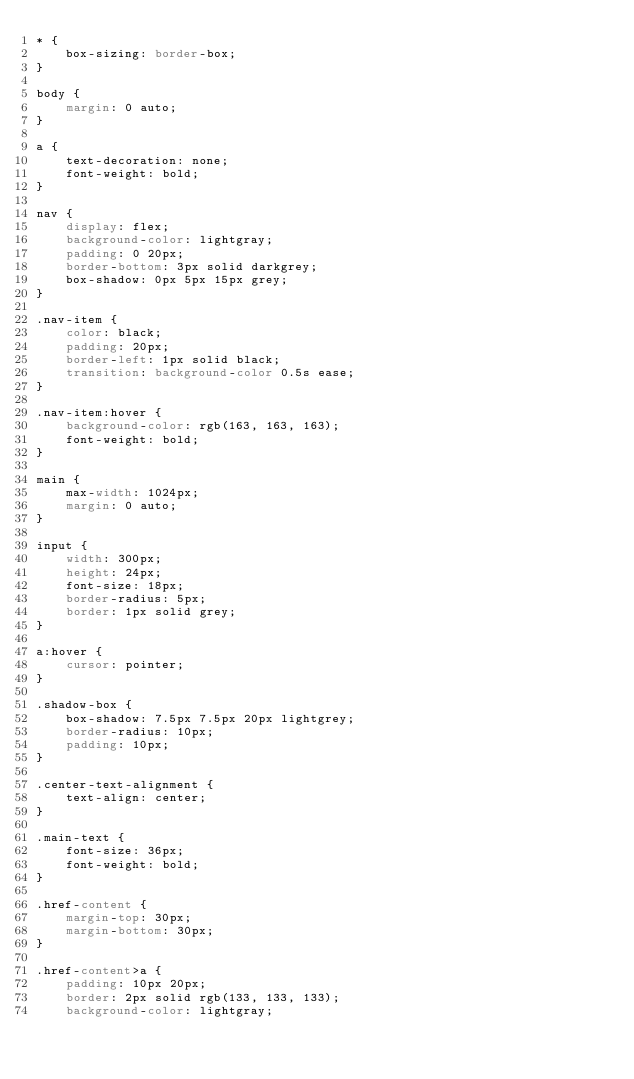<code> <loc_0><loc_0><loc_500><loc_500><_CSS_>* {
    box-sizing: border-box;
}

body {
    margin: 0 auto;
}

a {
    text-decoration: none;
    font-weight: bold;
}

nav {
    display: flex;
    background-color: lightgray;
    padding: 0 20px;
    border-bottom: 3px solid darkgrey;
    box-shadow: 0px 5px 15px grey;
}

.nav-item {
    color: black;
    padding: 20px;
    border-left: 1px solid black;
    transition: background-color 0.5s ease;
}

.nav-item:hover {
    background-color: rgb(163, 163, 163);
    font-weight: bold;
}

main {
    max-width: 1024px;
    margin: 0 auto;
}

input {
    width: 300px;
    height: 24px;
    font-size: 18px;
    border-radius: 5px;
    border: 1px solid grey;
}

a:hover {
    cursor: pointer;
}

.shadow-box {
    box-shadow: 7.5px 7.5px 20px lightgrey;
    border-radius: 10px;
    padding: 10px;
}

.center-text-alignment {
    text-align: center;
}

.main-text {
    font-size: 36px;
    font-weight: bold;
}

.href-content {
    margin-top: 30px;
    margin-bottom: 30px;
}

.href-content>a {
    padding: 10px 20px;
    border: 2px solid rgb(133, 133, 133);
    background-color: lightgray;</code> 